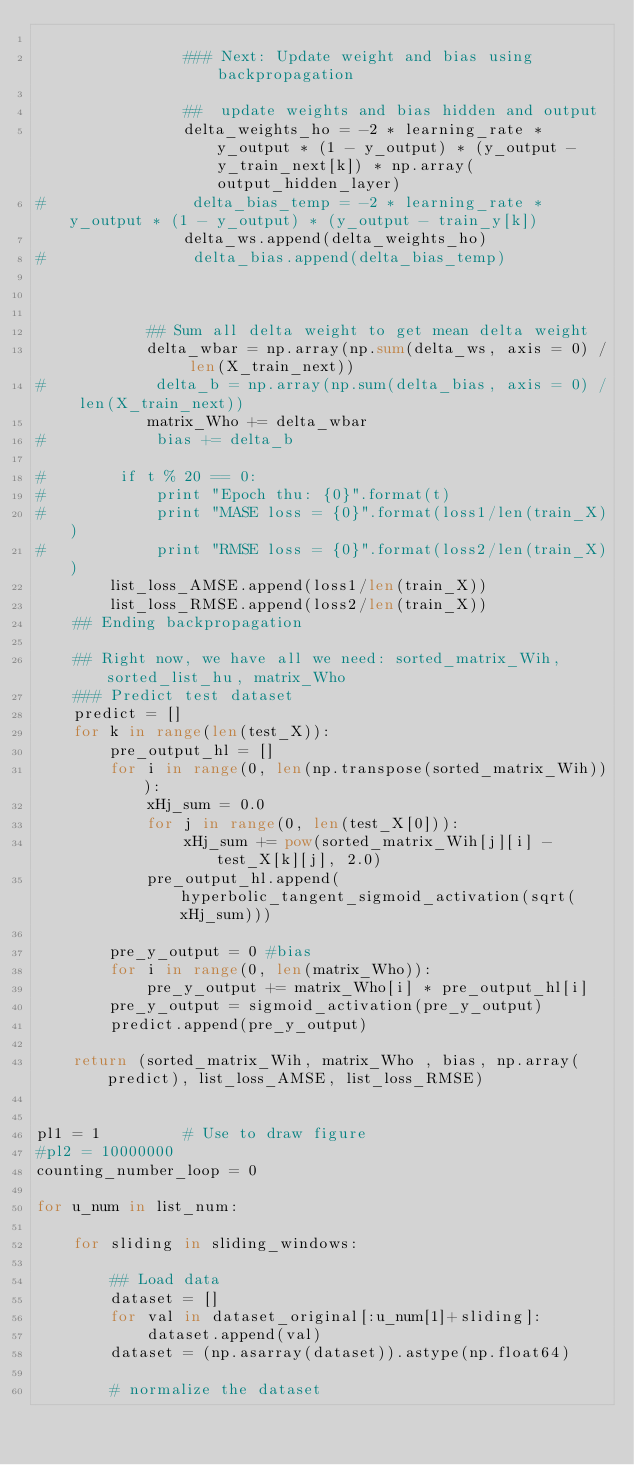Convert code to text. <code><loc_0><loc_0><loc_500><loc_500><_Python_>       
                ### Next: Update weight and bias using backpropagation
                
                ##  update weights and bias hidden and output
                delta_weights_ho = -2 * learning_rate * y_output * (1 - y_output) * (y_output - y_train_next[k]) * np.array(output_hidden_layer) 
#                delta_bias_temp = -2 * learning_rate * y_output * (1 - y_output) * (y_output - train_y[k]) 
                delta_ws.append(delta_weights_ho)
#                delta_bias.append(delta_bias_temp)
                

                
            ## Sum all delta weight to get mean delta weight
            delta_wbar = np.array(np.sum(delta_ws, axis = 0) / len(X_train_next))
#            delta_b = np.array(np.sum(delta_bias, axis = 0) / len(X_train_next))
            matrix_Who += delta_wbar
#            bias += delta_b
        
#        if t % 20 == 0:
#            print "Epoch thu: {0}".format(t)
#            print "MASE loss = {0}".format(loss1/len(train_X))
#            print "RMSE loss = {0}".format(loss2/len(train_X))
        list_loss_AMSE.append(loss1/len(train_X))
        list_loss_RMSE.append(loss2/len(train_X))
    ## Ending backpropagation
    
    ## Right now, we have all we need: sorted_matrix_Wih, sorted_list_hu, matrix_Who
    ### Predict test dataset
    predict = []
    for k in range(len(test_X)):
        pre_output_hl = []
        for i in range(0, len(np.transpose(sorted_matrix_Wih))):
            xHj_sum = 0.0
            for j in range(0, len(test_X[0])):
                xHj_sum += pow(sorted_matrix_Wih[j][i] - test_X[k][j], 2.0)
            pre_output_hl.append(hyperbolic_tangent_sigmoid_activation(sqrt(xHj_sum)))
        
        pre_y_output = 0 #bias
        for i in range(0, len(matrix_Who)):
            pre_y_output += matrix_Who[i] * pre_output_hl[i]
        pre_y_output = sigmoid_activation(pre_y_output)
        predict.append(pre_y_output)
     
    return (sorted_matrix_Wih, matrix_Who , bias, np.array(predict), list_loss_AMSE, list_loss_RMSE)


pl1 = 1         # Use to draw figure
#pl2 = 10000000
counting_number_loop = 0

for u_num in list_num:
    
    for sliding in sliding_windows:
        
        ## Load data
        dataset = []
        for val in dataset_original[:u_num[1]+sliding]:
            dataset.append(val)
        dataset = (np.asarray(dataset)).astype(np.float64)
        
        # normalize the dataset</code> 